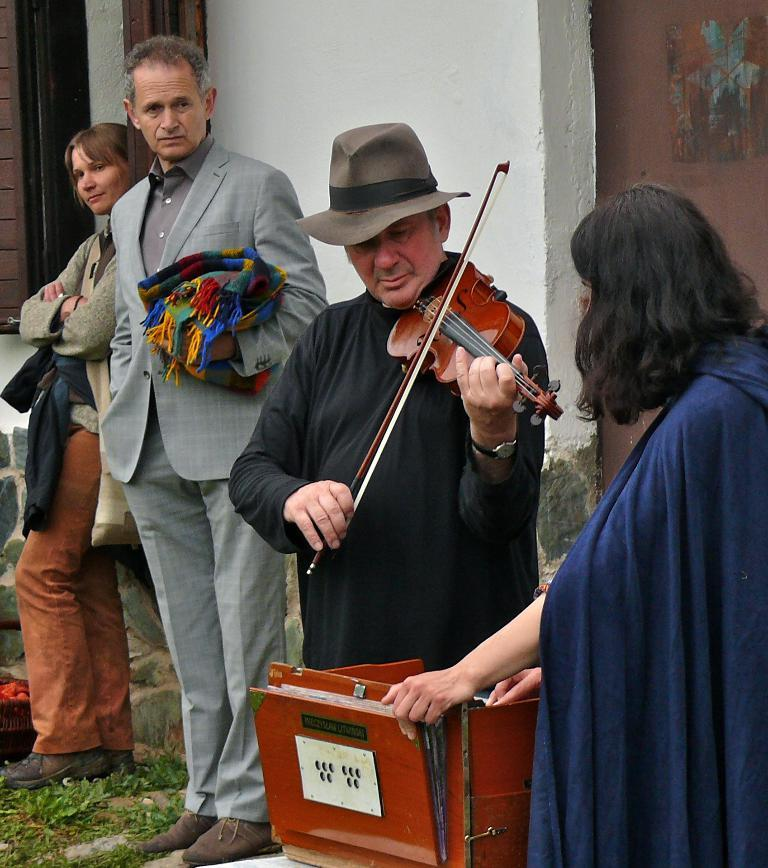How many people are present in the image? There are four people in the image, two men and two women. What are the men doing in the image? One man is holding a violin and playing it. What are the women doing in the image? One woman is playing an accordion. What can be seen in the background of the image? There is a wall visible in the background of the image. What type of selection is being made by the ducks in the image? There are no ducks present in the image, so there is no selection being made. Is there a tent visible in the image? No, there is no tent present in the image. 